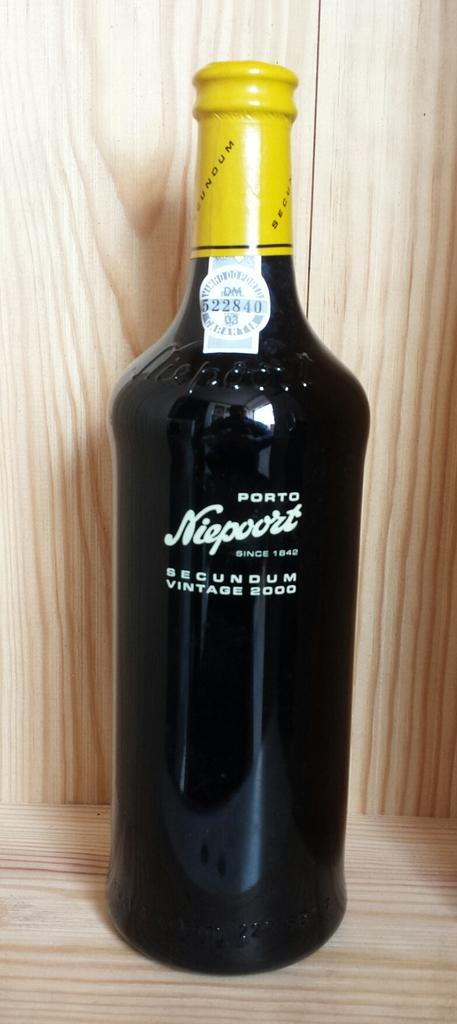<image>
Give a short and clear explanation of the subsequent image. A black botlle of niepoort branded wine with a yellow top. 